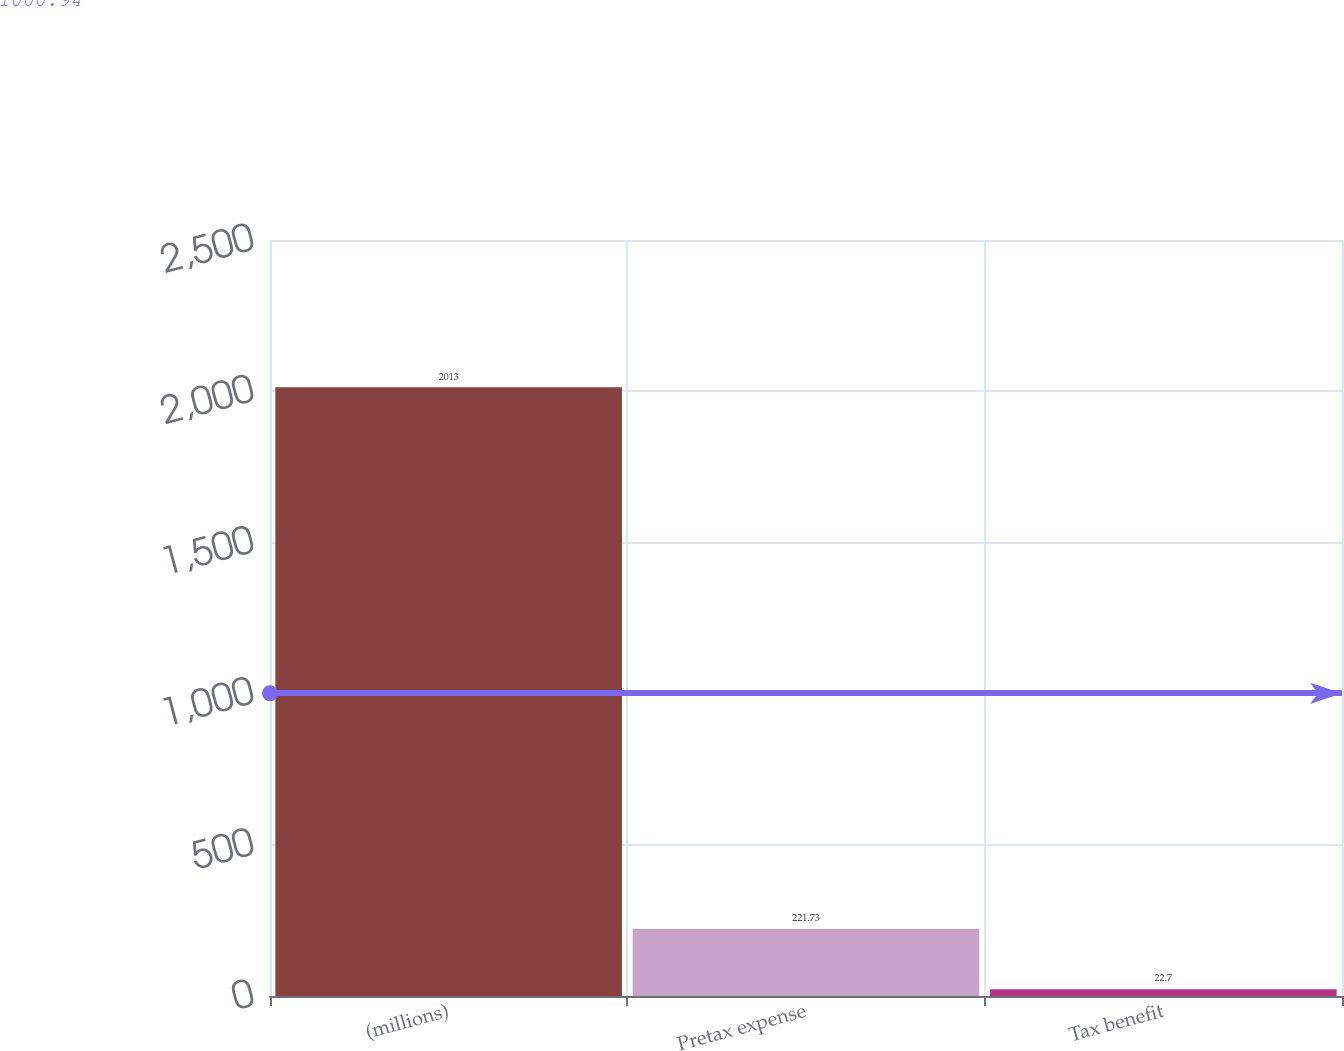Convert chart to OTSL. <chart><loc_0><loc_0><loc_500><loc_500><bar_chart><fcel>(millions)<fcel>Pretax expense<fcel>Tax benefit<nl><fcel>2013<fcel>221.73<fcel>22.7<nl></chart> 